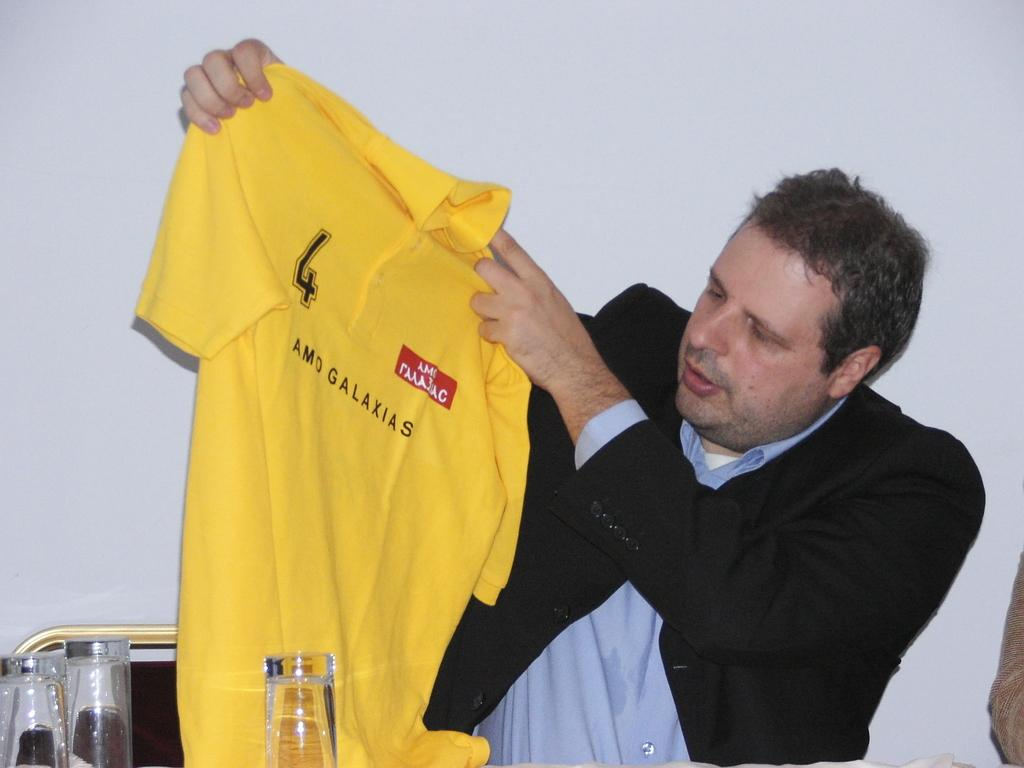<image>
Give a short and clear explanation of the subsequent image. A man holding up a yellow shirt with Galaxias on it. 